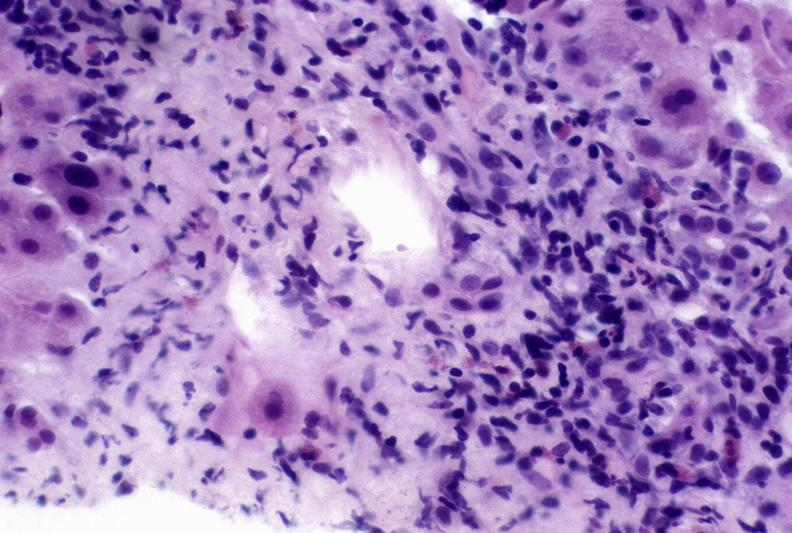does exposure show autoimmune hepatitis?
Answer the question using a single word or phrase. No 